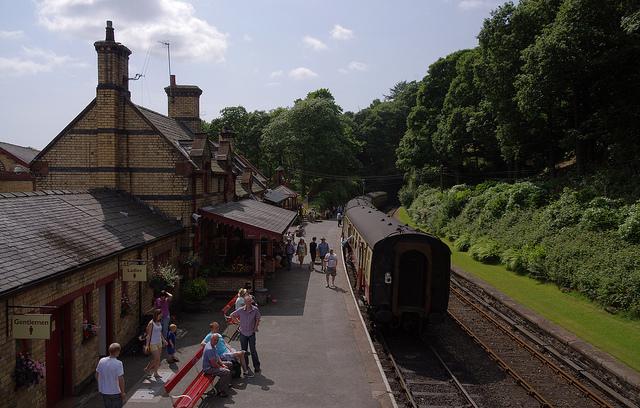What color is the picture?
Write a very short answer. Green. What does the sign say?
Be succinct. Gentlemen. Is this a real train?
Answer briefly. Yes. How many houses are there?
Quick response, please. 0. What is the weather like?
Give a very brief answer. Sunny. What color are the seats?
Quick response, please. Red. How many people on the path?
Give a very brief answer. 4. Is it raining where this man is?
Give a very brief answer. No. Are the people farmers?
Keep it brief. No. What season is it probably?
Short answer required. Summer. What color is the train?
Write a very short answer. Brown. Do you think the train is moving?
Be succinct. Yes. Is the train above the river?
Give a very brief answer. No. How many people are in the photo?
Be succinct. 10. Are there stairs in this photo?
Concise answer only. No. What season is it?
Quick response, please. Summer. Are they walking uphill?
Concise answer only. No. Is there a  clock in the picture?
Give a very brief answer. No. 